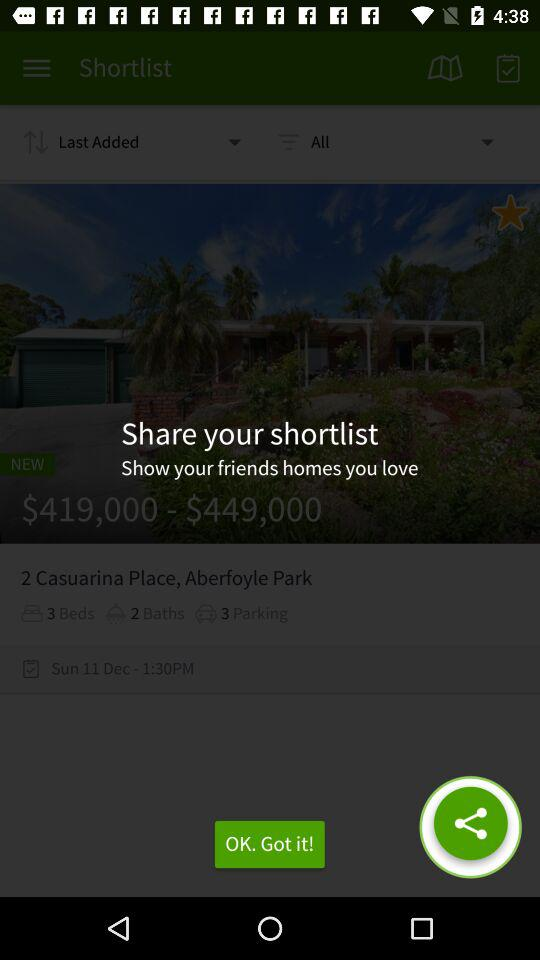How many baths are there in this house?
Answer the question using a single word or phrase. 2 